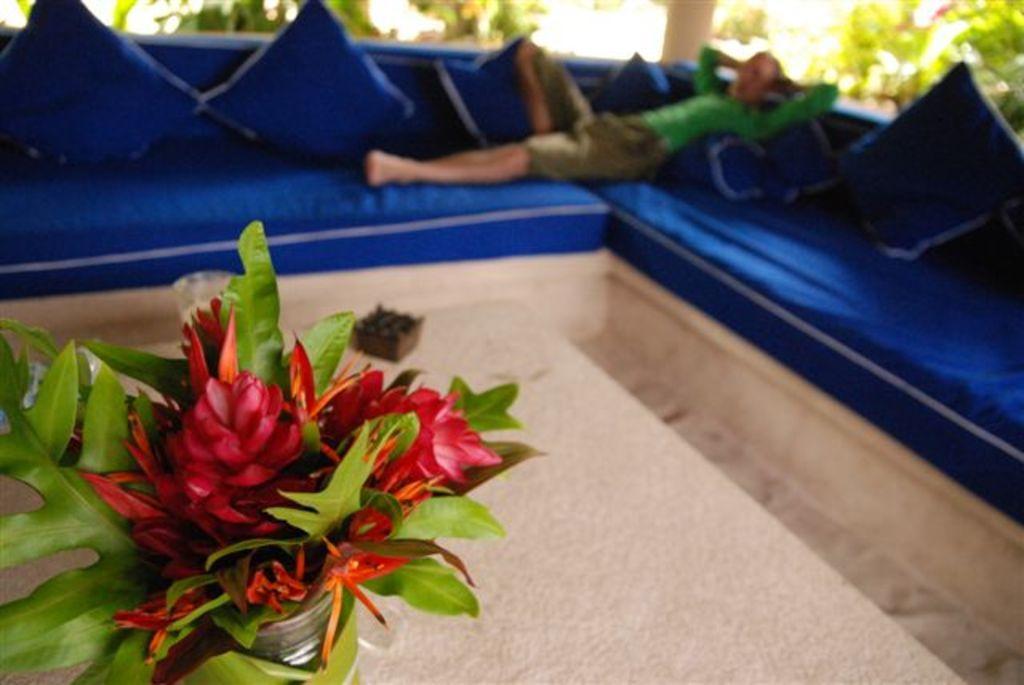Can you describe this image briefly? In this picture we can see a house plant and a wooden object on a cream surface. We can see a person lying on a sofa. There are few pillows on this sofa. We can see some plants and a pillar in the background. 